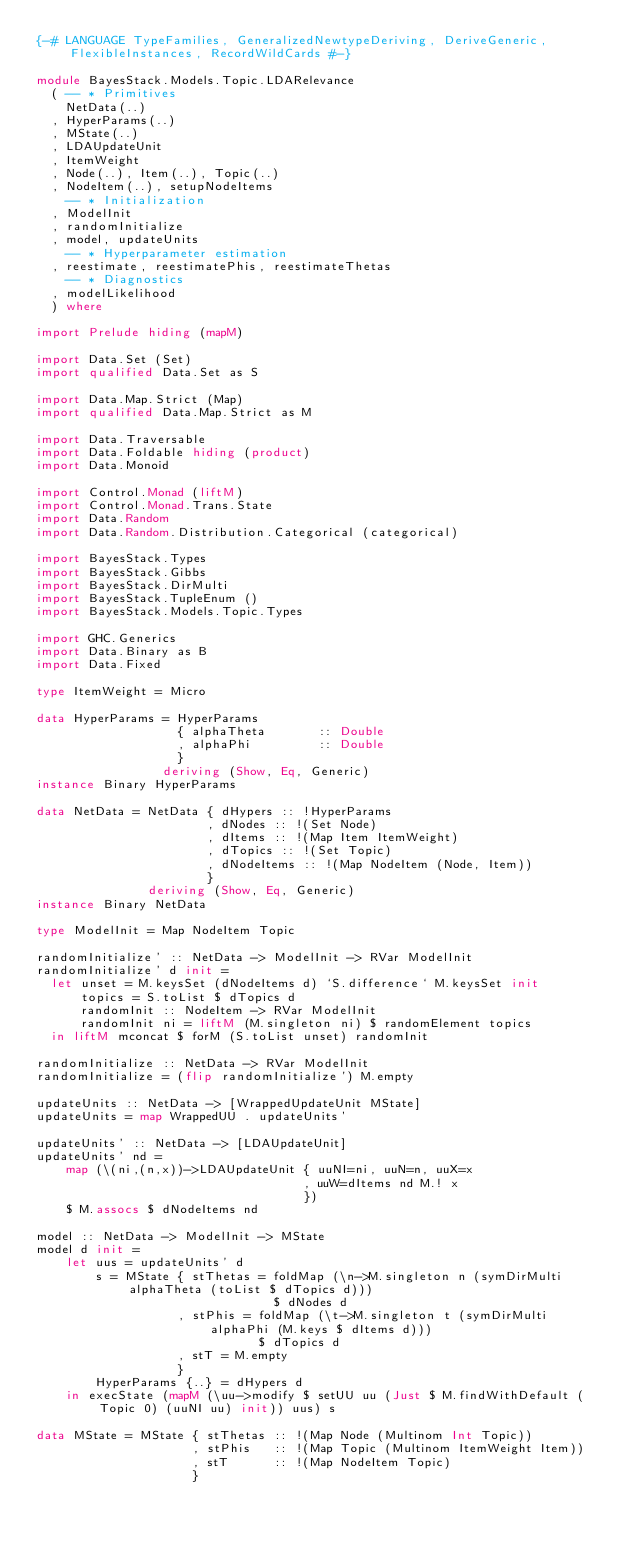Convert code to text. <code><loc_0><loc_0><loc_500><loc_500><_Haskell_>{-# LANGUAGE TypeFamilies, GeneralizedNewtypeDeriving, DeriveGeneric, FlexibleInstances, RecordWildCards #-}

module BayesStack.Models.Topic.LDARelevance
  ( -- * Primitives
    NetData(..)
  , HyperParams(..)
  , MState(..)
  , LDAUpdateUnit
  , ItemWeight
  , Node(..), Item(..), Topic(..)
  , NodeItem(..), setupNodeItems
    -- * Initialization
  , ModelInit
  , randomInitialize
  , model, updateUnits
    -- * Hyperparameter estimation
  , reestimate, reestimatePhis, reestimateThetas
    -- * Diagnostics
  , modelLikelihood
  ) where

import Prelude hiding (mapM)

import Data.Set (Set)
import qualified Data.Set as S

import Data.Map.Strict (Map)
import qualified Data.Map.Strict as M

import Data.Traversable
import Data.Foldable hiding (product)
import Data.Monoid

import Control.Monad (liftM)
import Control.Monad.Trans.State
import Data.Random
import Data.Random.Distribution.Categorical (categorical)

import BayesStack.Types
import BayesStack.Gibbs
import BayesStack.DirMulti
import BayesStack.TupleEnum ()
import BayesStack.Models.Topic.Types

import GHC.Generics
import Data.Binary as B
import Data.Fixed

type ItemWeight = Micro

data HyperParams = HyperParams
                   { alphaTheta       :: Double
                   , alphaPhi         :: Double
                   }
                 deriving (Show, Eq, Generic)
instance Binary HyperParams     

data NetData = NetData { dHypers :: !HyperParams
                       , dNodes :: !(Set Node)
                       , dItems :: !(Map Item ItemWeight)
                       , dTopics :: !(Set Topic)
                       , dNodeItems :: !(Map NodeItem (Node, Item))
                       }
               deriving (Show, Eq, Generic)
instance Binary NetData

type ModelInit = Map NodeItem Topic

randomInitialize' :: NetData -> ModelInit -> RVar ModelInit
randomInitialize' d init =
  let unset = M.keysSet (dNodeItems d) `S.difference` M.keysSet init
      topics = S.toList $ dTopics d
      randomInit :: NodeItem -> RVar ModelInit
      randomInit ni = liftM (M.singleton ni) $ randomElement topics
  in liftM mconcat $ forM (S.toList unset) randomInit

randomInitialize :: NetData -> RVar ModelInit
randomInitialize = (flip randomInitialize') M.empty

updateUnits :: NetData -> [WrappedUpdateUnit MState]
updateUnits = map WrappedUU . updateUnits'

updateUnits' :: NetData -> [LDAUpdateUnit]
updateUnits' nd =
    map (\(ni,(n,x))->LDAUpdateUnit { uuNI=ni, uuN=n, uuX=x
                                    , uuW=dItems nd M.! x
                                    })
    $ M.assocs $ dNodeItems nd

model :: NetData -> ModelInit -> MState
model d init =
    let uus = updateUnits' d
        s = MState { stThetas = foldMap (\n->M.singleton n (symDirMulti alphaTheta (toList $ dTopics d)))
                                $ dNodes d
                   , stPhis = foldMap (\t->M.singleton t (symDirMulti alphaPhi (M.keys $ dItems d)))
                              $ dTopics d
                   , stT = M.empty
                   }
        HyperParams {..} = dHypers d
    in execState (mapM (\uu->modify $ setUU uu (Just $ M.findWithDefault (Topic 0) (uuNI uu) init)) uus) s

data MState = MState { stThetas :: !(Map Node (Multinom Int Topic))
                     , stPhis   :: !(Map Topic (Multinom ItemWeight Item))
                     , stT      :: !(Map NodeItem Topic)
                     }</code> 